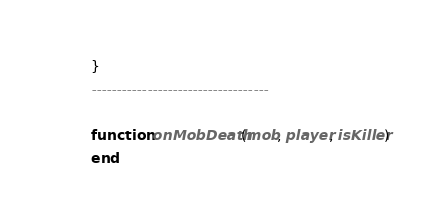Convert code to text. <code><loc_0><loc_0><loc_500><loc_500><_Lua_>}
-----------------------------------

function onMobDeath(mob, player, isKiller)
end
</code> 